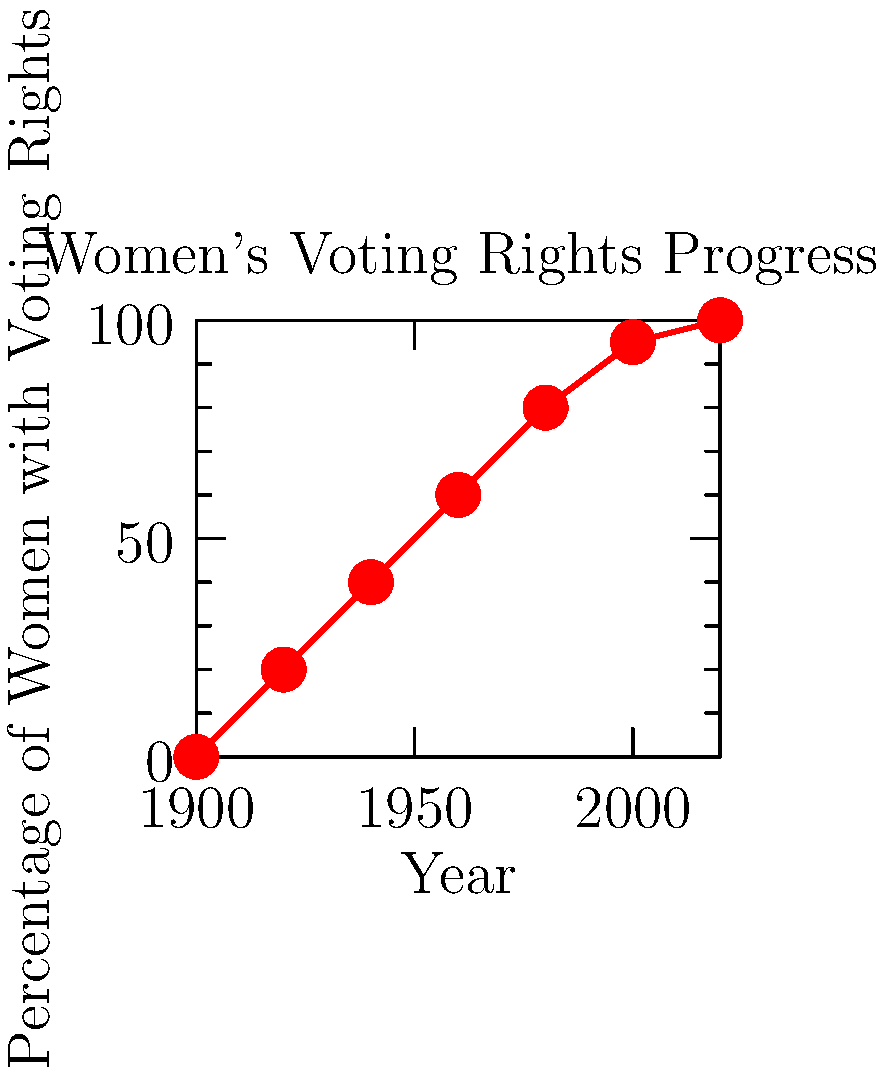The graph shows the progress of women's voting rights over time. If we consider the vector $\vec{v} = (120, 100)$ representing the change from 1900 to 2020, what scaled vector would represent the change from 1900 to 1940? To solve this problem, we need to follow these steps:

1. Identify the total change represented by $\vec{v}$:
   - Time span: 2020 - 1900 = 120 years
   - Percentage change: 100% - 0% = 100%

2. Identify the change from 1900 to 1940:
   - Time span: 1940 - 1900 = 40 years
   - Percentage change: 40% - 0% = 40%

3. Calculate the scaling factor:
   - For time: $40/120 = 1/3$
   - For percentage: $40/100 = 2/5$

4. Apply the scaling to $\vec{v}$:
   - x-component: $120 \times (1/3) = 40$
   - y-component: $100 \times (2/5) = 40$

Therefore, the scaled vector representing the change from 1900 to 1940 is $(40, 40)$.
Answer: $(40, 40)$ 